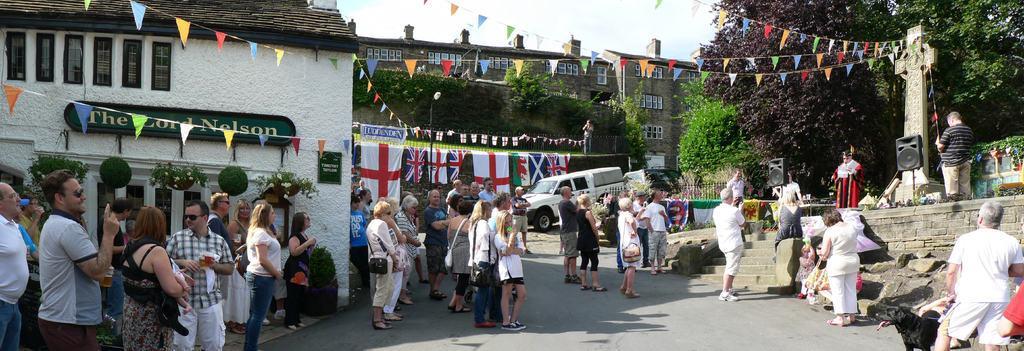How would you summarize this image in a sentence or two? In this picture I can see there is a road and there are a few people standing, there is a person standing on the dais to the right and there are trees, plants, a car, buildings and there are doors, windows, there are few decorations and the sky is clear. 